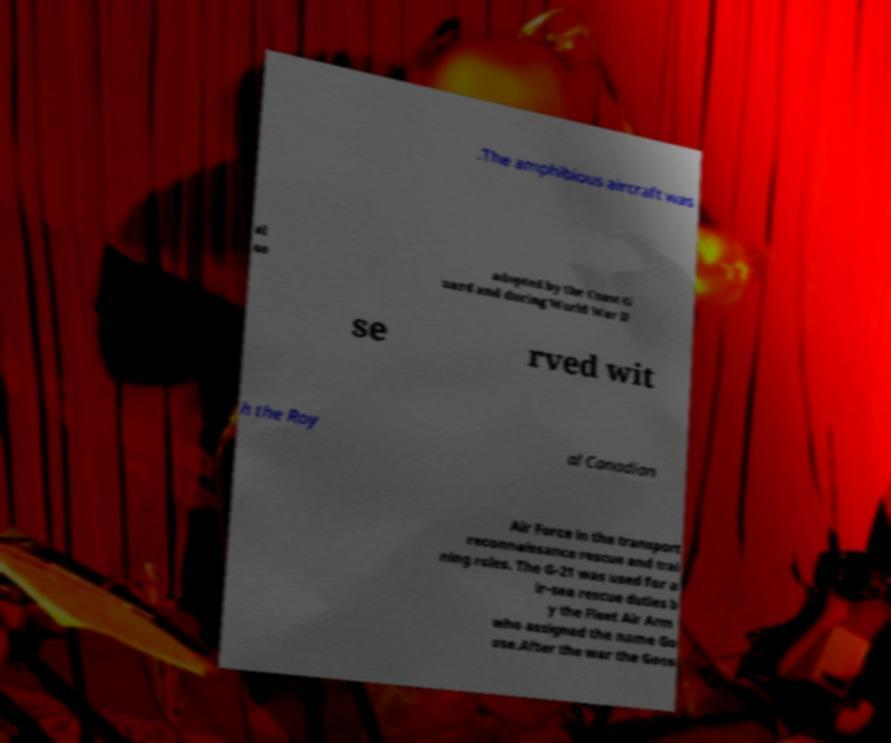I need the written content from this picture converted into text. Can you do that? .The amphibious aircraft was al so adopted by the Coast G uard and during World War II se rved wit h the Roy al Canadian Air Force in the transport reconnaissance rescue and trai ning roles. The G-21 was used for a ir-sea rescue duties b y the Fleet Air Arm who assigned the name Go ose.After the war the Goos 